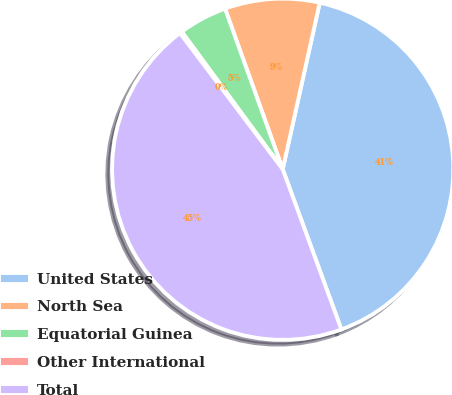<chart> <loc_0><loc_0><loc_500><loc_500><pie_chart><fcel>United States<fcel>North Sea<fcel>Equatorial Guinea<fcel>Other International<fcel>Total<nl><fcel>40.93%<fcel>8.97%<fcel>4.59%<fcel>0.21%<fcel>45.3%<nl></chart> 